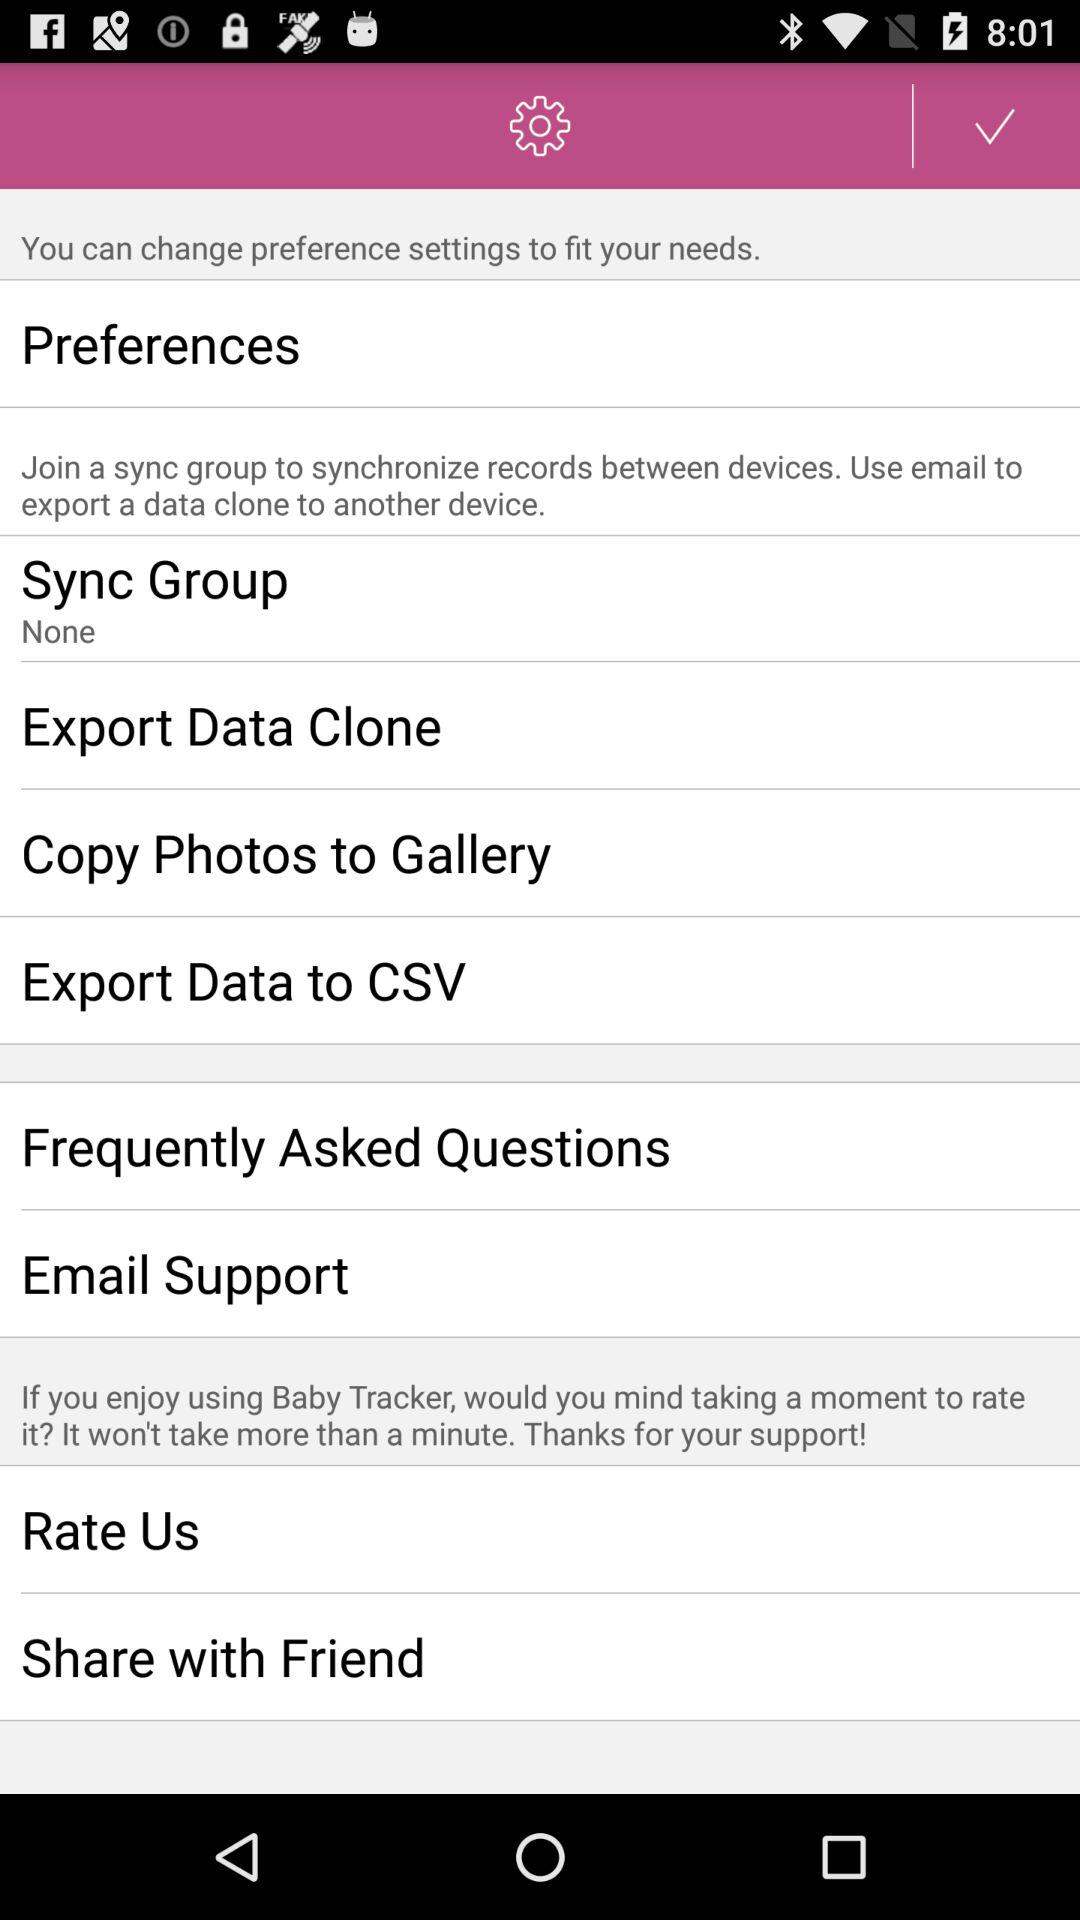Is "Rate Us" checked or unchecked?
When the provided information is insufficient, respond with <no answer>. <no answer> 